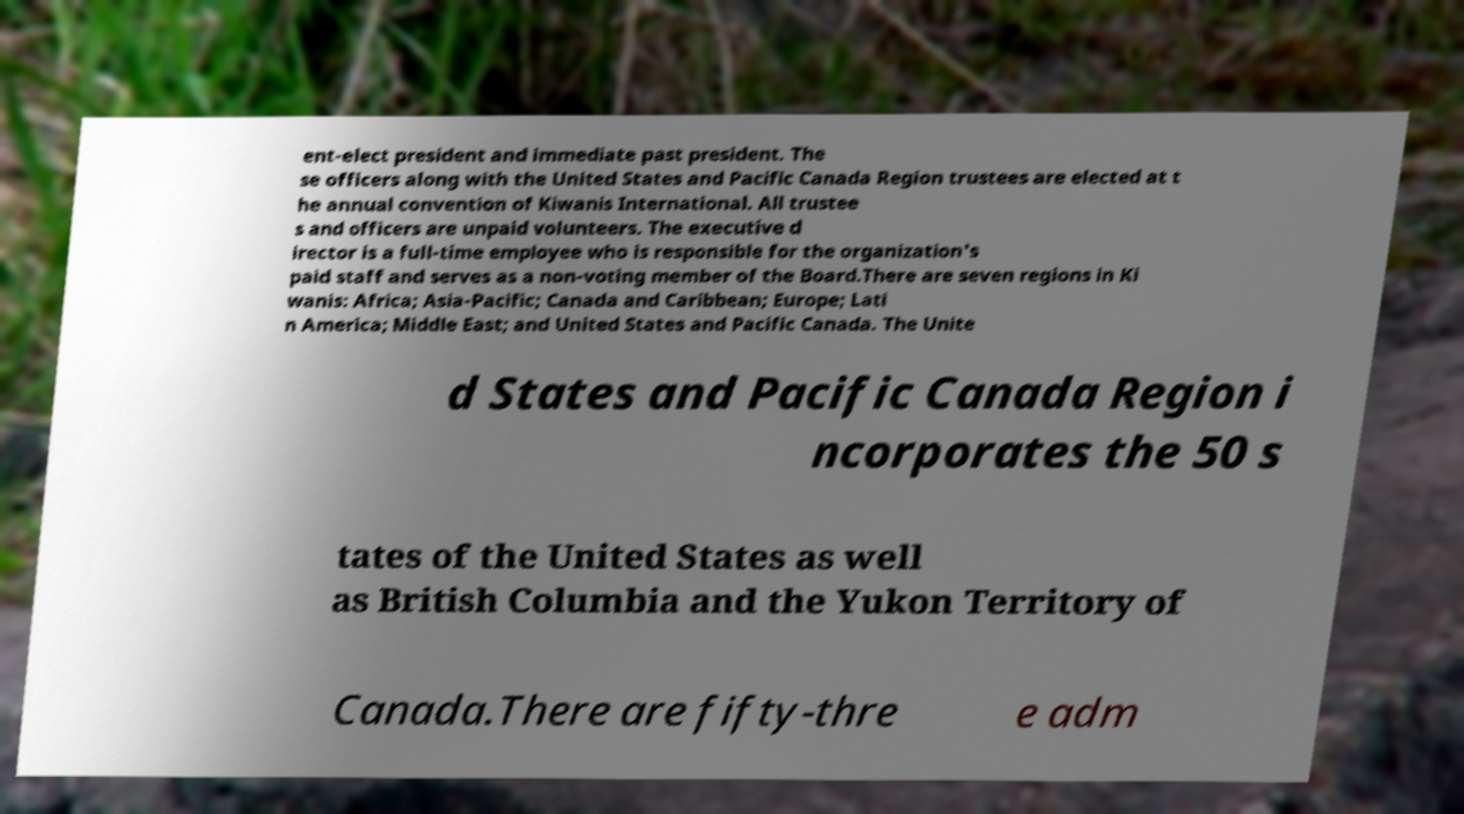Can you read and provide the text displayed in the image?This photo seems to have some interesting text. Can you extract and type it out for me? ent-elect president and immediate past president. The se officers along with the United States and Pacific Canada Region trustees are elected at t he annual convention of Kiwanis International. All trustee s and officers are unpaid volunteers. The executive d irector is a full-time employee who is responsible for the organization's paid staff and serves as a non-voting member of the Board.There are seven regions in Ki wanis: Africa; Asia-Pacific; Canada and Caribbean; Europe; Lati n America; Middle East; and United States and Pacific Canada. The Unite d States and Pacific Canada Region i ncorporates the 50 s tates of the United States as well as British Columbia and the Yukon Territory of Canada.There are fifty-thre e adm 